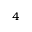Convert formula to latex. <formula><loc_0><loc_0><loc_500><loc_500>_ { 4 }</formula> 